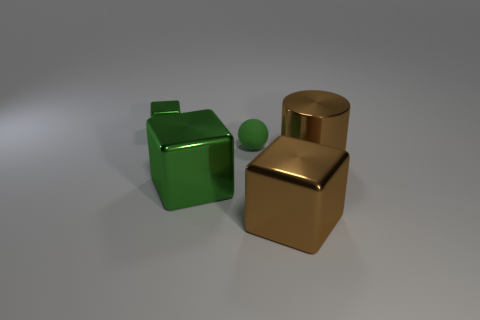Subtract all large green blocks. How many blocks are left? 2 Add 4 brown objects. How many objects exist? 9 Subtract all gray cylinders. How many green cubes are left? 2 Subtract all brown blocks. How many blocks are left? 2 Subtract all balls. How many objects are left? 4 Subtract all cyan cylinders. Subtract all purple blocks. How many cylinders are left? 1 Subtract all green rubber spheres. Subtract all cubes. How many objects are left? 1 Add 2 green shiny cubes. How many green shiny cubes are left? 4 Add 2 small green rubber balls. How many small green rubber balls exist? 3 Subtract 1 green balls. How many objects are left? 4 